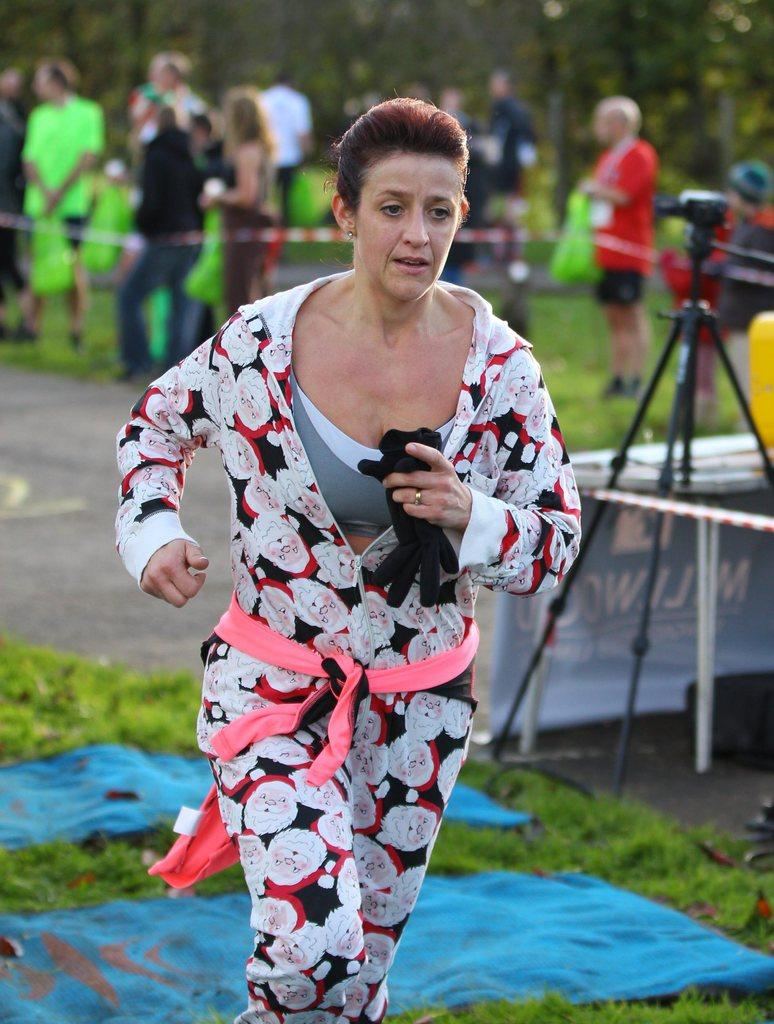What are the persons in the image wearing? The persons in the image are wearing clothes. Where are the clothes located besides on the persons? There are clothes on the grass in the image. What can be seen on the right side of the image? There is a tripod on the right side of the image. Can you see any blades of grass in the image? The image does not specifically mention blades of grass, but it does mention that there are clothes on the grass. How many robins are perched on the tripod in the image? There are no robins present in the image; it only features persons wearing clothes, clothes on the grass, and a tripod. 